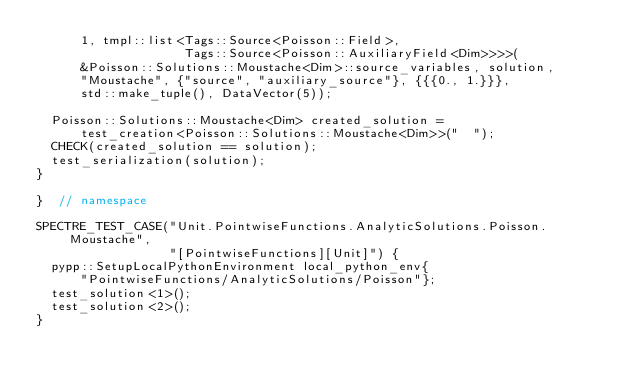Convert code to text. <code><loc_0><loc_0><loc_500><loc_500><_C++_>      1, tmpl::list<Tags::Source<Poisson::Field>,
                    Tags::Source<Poisson::AuxiliaryField<Dim>>>>(
      &Poisson::Solutions::Moustache<Dim>::source_variables, solution,
      "Moustache", {"source", "auxiliary_source"}, {{{0., 1.}}},
      std::make_tuple(), DataVector(5));

  Poisson::Solutions::Moustache<Dim> created_solution =
      test_creation<Poisson::Solutions::Moustache<Dim>>("  ");
  CHECK(created_solution == solution);
  test_serialization(solution);
}

}  // namespace

SPECTRE_TEST_CASE("Unit.PointwiseFunctions.AnalyticSolutions.Poisson.Moustache",
                  "[PointwiseFunctions][Unit]") {
  pypp::SetupLocalPythonEnvironment local_python_env{
      "PointwiseFunctions/AnalyticSolutions/Poisson"};
  test_solution<1>();
  test_solution<2>();
}
</code> 